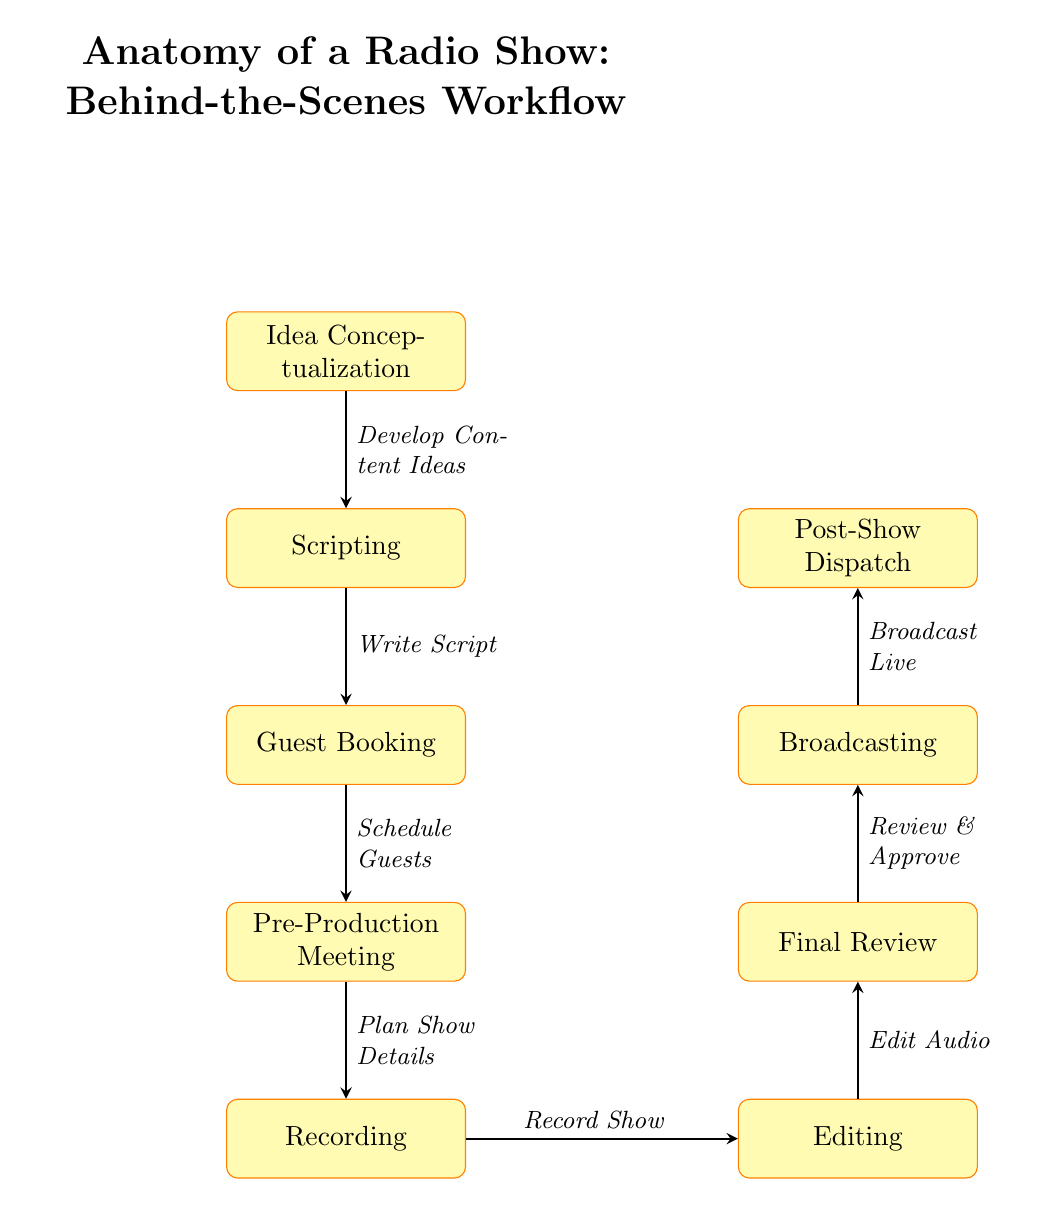What is the first step in the workflow? The diagram starts with the node labeled "Idea Conceptualization," which is positioned at the top of the flowchart. This indicates that it is the first step in the process.
Answer: Idea Conceptualization How many total steps are there in the workflow? The diagram lists eight distinct nodes, indicating steps in the workflow from "Idea Conceptualization" to "Post-Show Dispatch." Counting these nodes gives a total of eight steps.
Answer: 8 What comes immediately after "Recording"? The diagram shows an arrow leading from "Recording" to "Editing," indicating that editing follows after the recording step in the workflow.
Answer: Editing What is the purpose of "Guest Booking"? The label "Guest Booking" in the diagram signifies that this step is about scheduling guests for the show, as stated in the text adjacent to the arrow pointing to this node.
Answer: Schedule Guests What is the final step in the process? The diagram ends with the node labeled "Post-Show Dispatch," which signifies that this is the last step that occurs after broadcasting the show.
Answer: Post-Show Dispatch What is the step between "Final Review" and "Broadcasting"? In the diagram, "Final Review" is directly connected to "Broadcasting" by an arrow, indicating that the final review process must be completed before broadcasting occurs.
Answer: Broadcasting How does the "Editing" process relate to "Recording"? The diagram illustrates a flow from "Recording" to "Editing," demonstrating that editing takes place after the recording of the show is completed.
Answer: Edit Audio Which step is directly before "Pre-Production Meeting"? Looking at the flow of the diagram, "Guest Booking" is the node immediately above "Pre-Production Meeting," indicating it comes directly before this step.
Answer: Guest Booking What is the overall theme of the diagram? The title at the top of the diagram specifies that the theme is about the "Anatomy of a Radio Show" and details the workflow from production to broadcast.
Answer: Anatomy of a Radio Show 